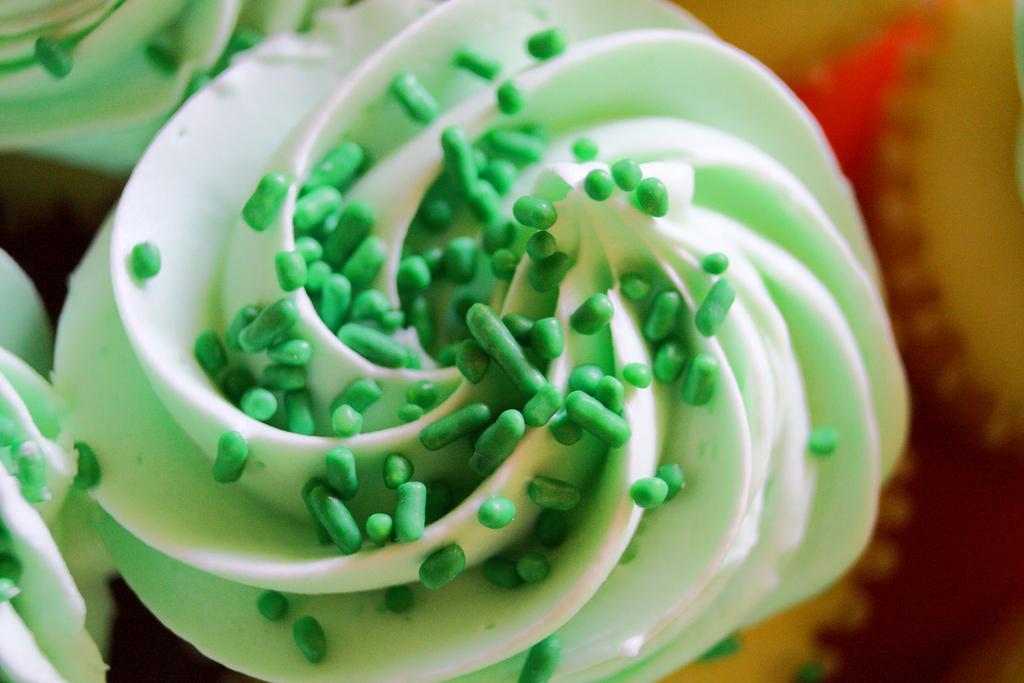In one or two sentences, can you explain what this image depicts? In this picture we can see some food items throughout the image. 